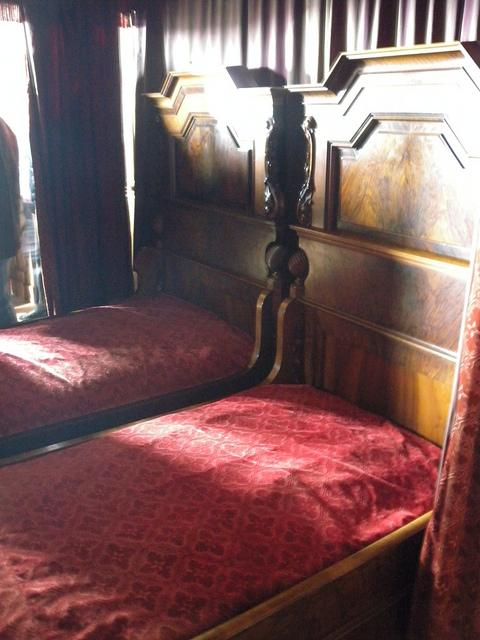What are the two areas decorated with red sheets used for?

Choices:
A) performing
B) serving
C) sleeping
D) gaming sleeping 